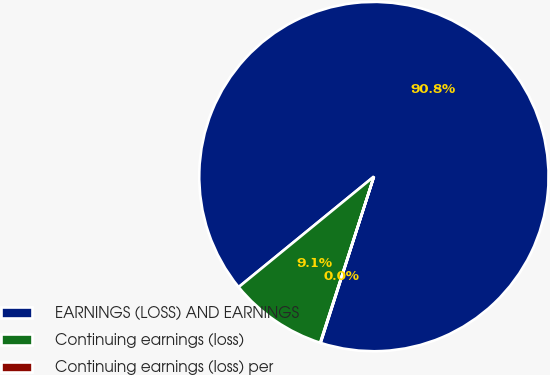Convert chart. <chart><loc_0><loc_0><loc_500><loc_500><pie_chart><fcel>EARNINGS (LOSS) AND EARNINGS<fcel>Continuing earnings (loss)<fcel>Continuing earnings (loss) per<nl><fcel>90.83%<fcel>9.12%<fcel>0.04%<nl></chart> 